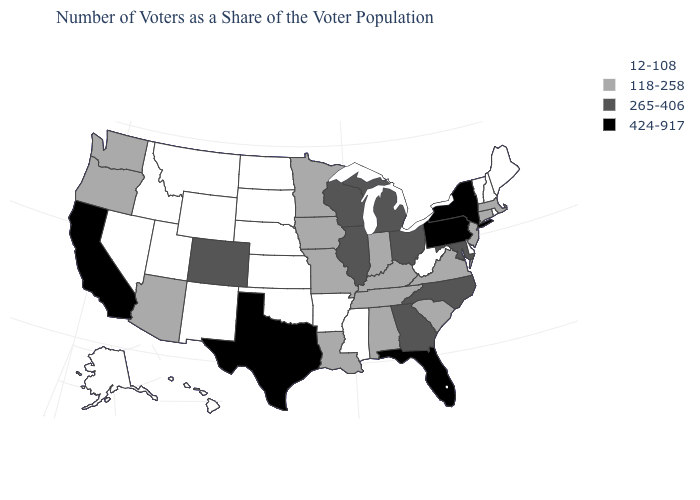Among the states that border Nebraska , which have the lowest value?
Quick response, please. Kansas, South Dakota, Wyoming. Which states have the lowest value in the West?
Concise answer only. Alaska, Hawaii, Idaho, Montana, Nevada, New Mexico, Utah, Wyoming. Does Utah have a lower value than Florida?
Answer briefly. Yes. What is the highest value in the USA?
Concise answer only. 424-917. What is the value of Mississippi?
Be succinct. 12-108. Does Wisconsin have the same value as Rhode Island?
Quick response, please. No. What is the value of Oregon?
Concise answer only. 118-258. Among the states that border Kentucky , which have the highest value?
Give a very brief answer. Illinois, Ohio. What is the value of Georgia?
Quick response, please. 265-406. What is the value of Wisconsin?
Answer briefly. 265-406. What is the highest value in the USA?
Concise answer only. 424-917. Name the states that have a value in the range 12-108?
Be succinct. Alaska, Arkansas, Delaware, Hawaii, Idaho, Kansas, Maine, Mississippi, Montana, Nebraska, Nevada, New Hampshire, New Mexico, North Dakota, Oklahoma, Rhode Island, South Dakota, Utah, Vermont, West Virginia, Wyoming. Does the map have missing data?
Answer briefly. No. Among the states that border Arizona , which have the highest value?
Quick response, please. California. Among the states that border Missouri , does Illinois have the highest value?
Concise answer only. Yes. 